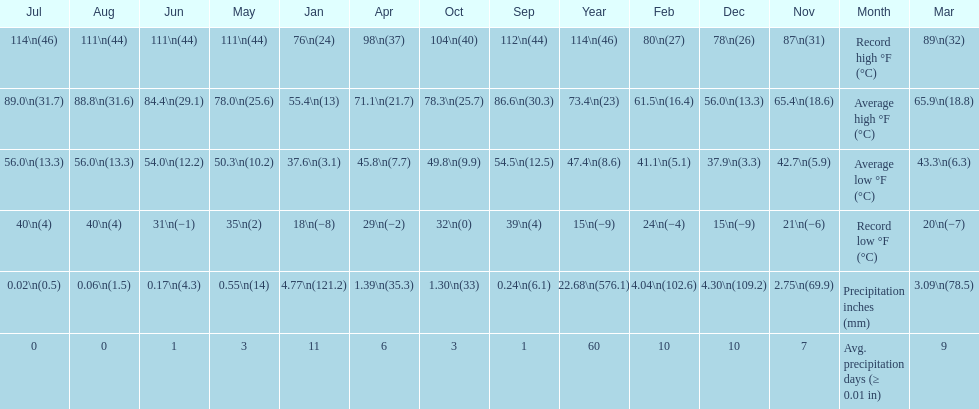How many months how a record low below 25 degrees? 6. 